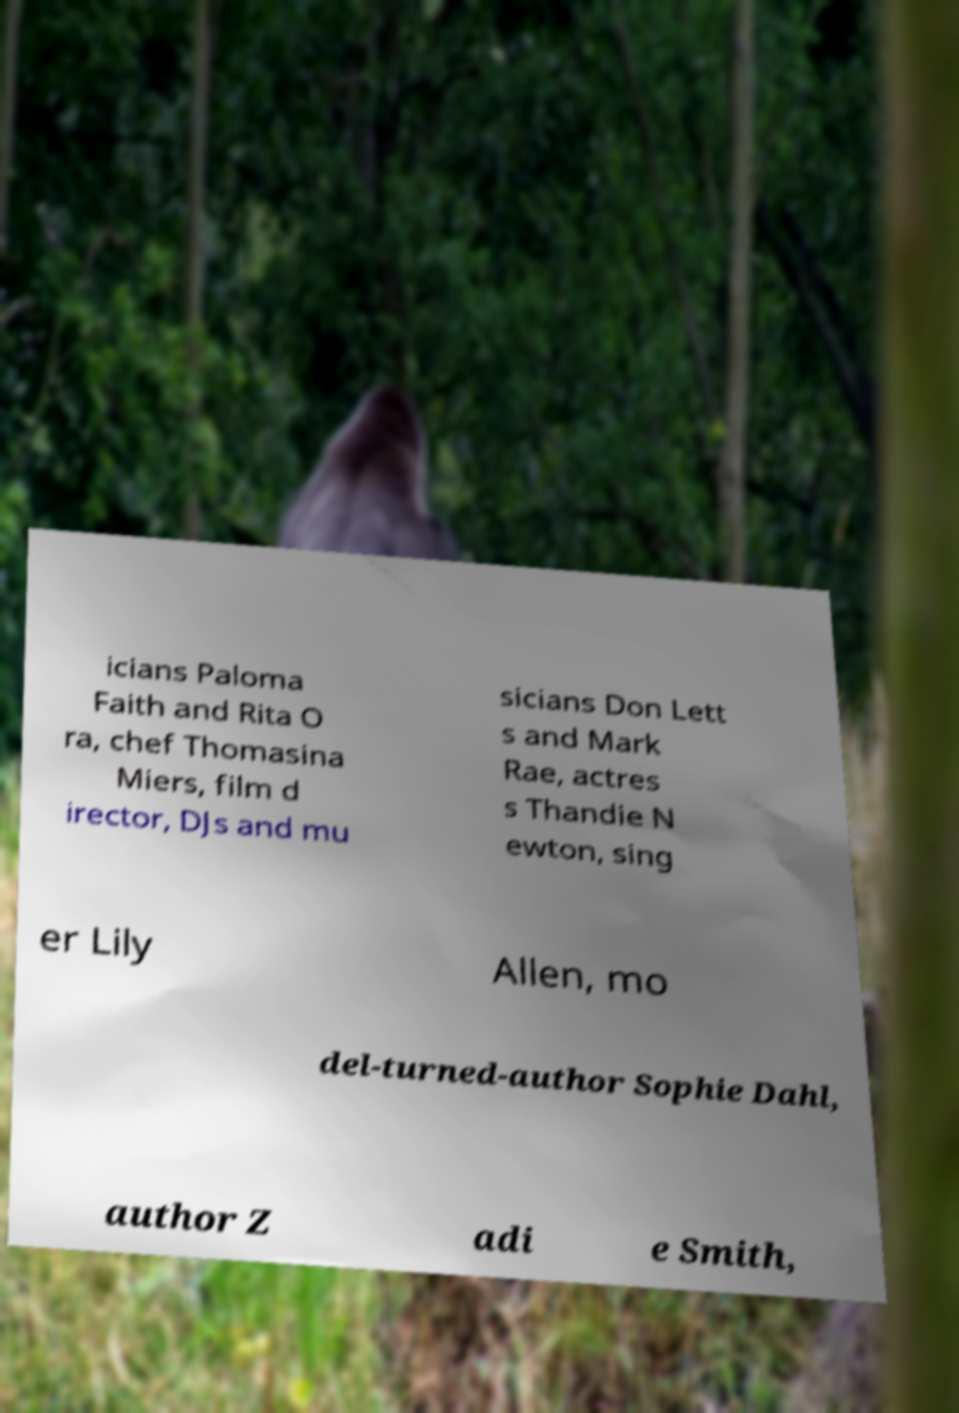Could you assist in decoding the text presented in this image and type it out clearly? icians Paloma Faith and Rita O ra, chef Thomasina Miers, film d irector, DJs and mu sicians Don Lett s and Mark Rae, actres s Thandie N ewton, sing er Lily Allen, mo del-turned-author Sophie Dahl, author Z adi e Smith, 